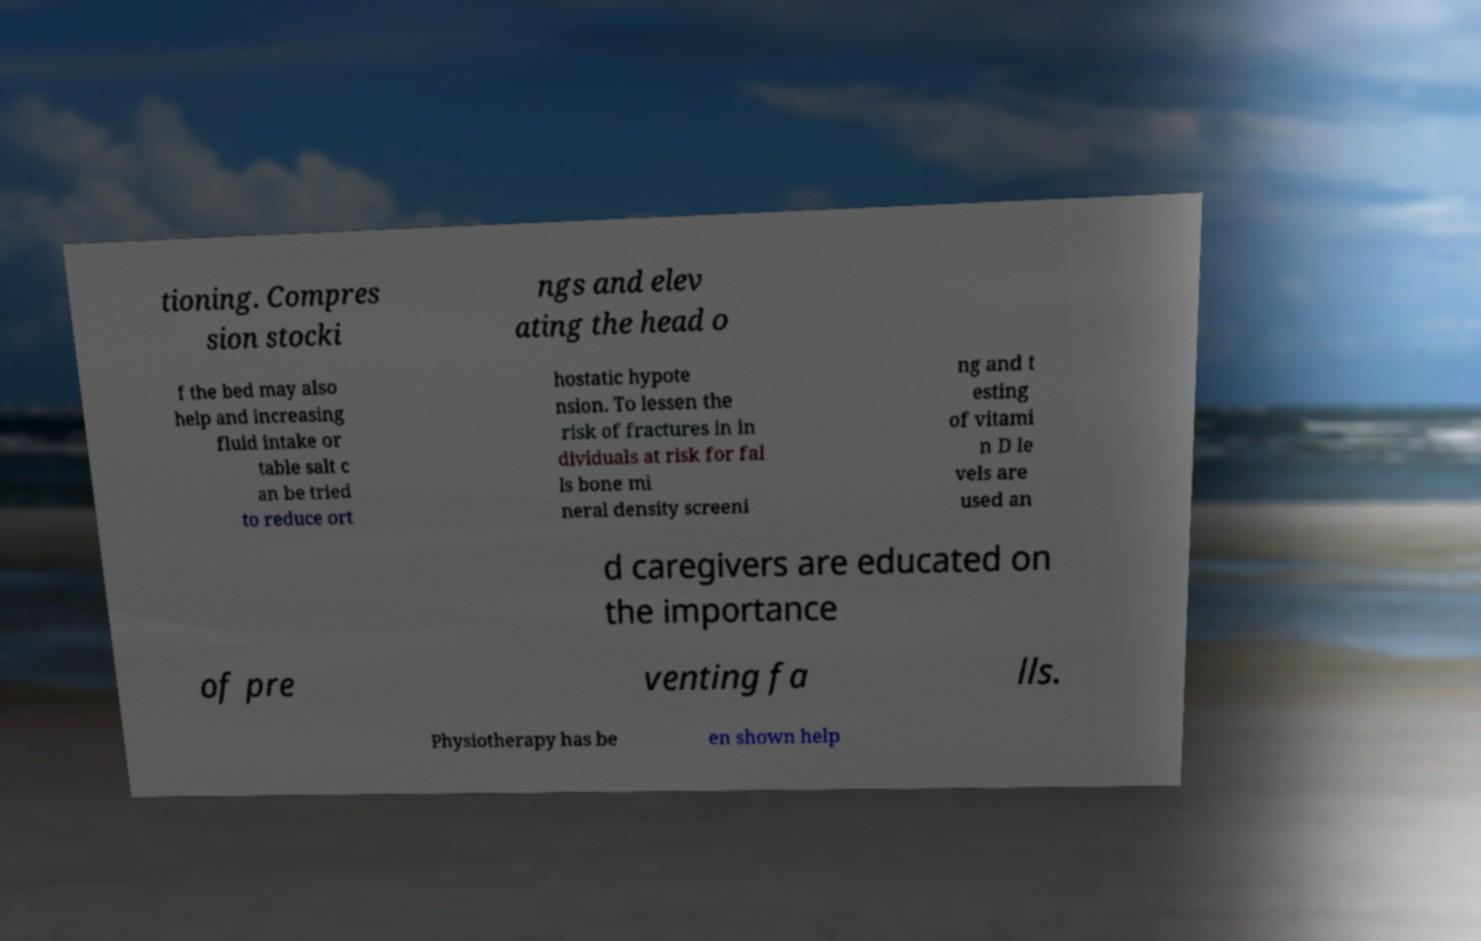What messages or text are displayed in this image? I need them in a readable, typed format. tioning. Compres sion stocki ngs and elev ating the head o f the bed may also help and increasing fluid intake or table salt c an be tried to reduce ort hostatic hypote nsion. To lessen the risk of fractures in in dividuals at risk for fal ls bone mi neral density screeni ng and t esting of vitami n D le vels are used an d caregivers are educated on the importance of pre venting fa lls. Physiotherapy has be en shown help 